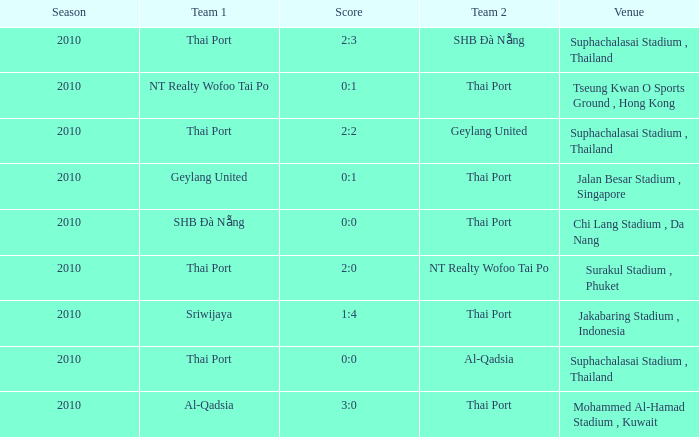At which site was the game played that resulted in a 2:3 score? Suphachalasai Stadium , Thailand. 